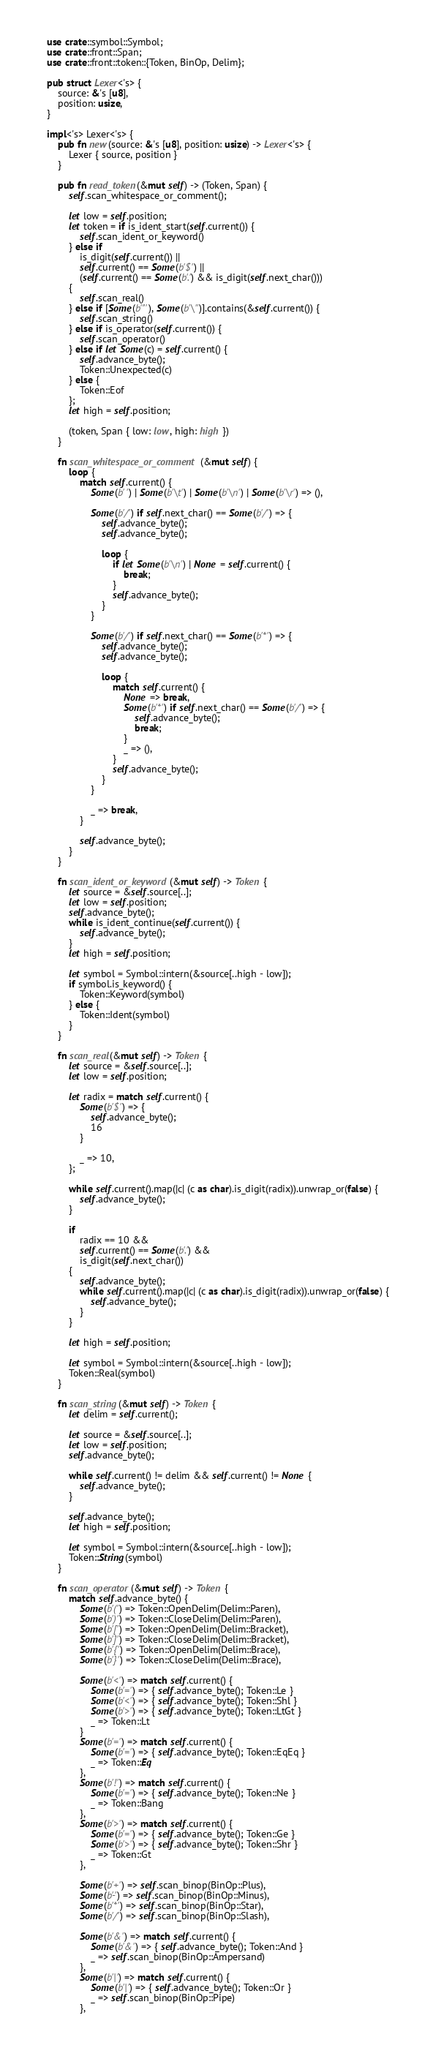Convert code to text. <code><loc_0><loc_0><loc_500><loc_500><_Rust_>use crate::symbol::Symbol;
use crate::front::Span;
use crate::front::token::{Token, BinOp, Delim};

pub struct Lexer<'s> {
    source: &'s [u8],
    position: usize,
}

impl<'s> Lexer<'s> {
    pub fn new(source: &'s [u8], position: usize) -> Lexer<'s> {
        Lexer { source, position }
    }

    pub fn read_token(&mut self) -> (Token, Span) {
        self.scan_whitespace_or_comment();

        let low = self.position;
        let token = if is_ident_start(self.current()) {
            self.scan_ident_or_keyword()
        } else if
            is_digit(self.current()) ||
            self.current() == Some(b'$') ||
            (self.current() == Some(b'.') && is_digit(self.next_char()))
        {
            self.scan_real()
        } else if [Some(b'"'), Some(b'\'')].contains(&self.current()) {
            self.scan_string()
        } else if is_operator(self.current()) {
            self.scan_operator()
        } else if let Some(c) = self.current() {
            self.advance_byte();
            Token::Unexpected(c)
        } else {
            Token::Eof
        };
        let high = self.position;

        (token, Span { low: low, high: high })
    }

    fn scan_whitespace_or_comment(&mut self) {
        loop {
            match self.current() {
                Some(b' ') | Some(b'\t') | Some(b'\n') | Some(b'\r') => (),

                Some(b'/') if self.next_char() == Some(b'/') => {
                    self.advance_byte();
                    self.advance_byte();

                    loop {
                        if let Some(b'\n') | None = self.current() {
                            break;
                        }
                        self.advance_byte();
                    }
                }

                Some(b'/') if self.next_char() == Some(b'*') => {
                    self.advance_byte();
                    self.advance_byte();

                    loop {
                        match self.current() {
                            None => break,
                            Some(b'*') if self.next_char() == Some(b'/') => {
                                self.advance_byte();
                                break;
                            }
                            _ => (),
                        }
                        self.advance_byte();
                    }
                }

                _ => break,
            }

            self.advance_byte();
        }
    }

    fn scan_ident_or_keyword(&mut self) -> Token {
        let source = &self.source[..];
        let low = self.position;
        self.advance_byte();
        while is_ident_continue(self.current()) {
            self.advance_byte();
        }
        let high = self.position;

        let symbol = Symbol::intern(&source[..high - low]);
        if symbol.is_keyword() {
            Token::Keyword(symbol)
        } else {
            Token::Ident(symbol)
        }
    }

    fn scan_real(&mut self) -> Token {
        let source = &self.source[..];
        let low = self.position;

        let radix = match self.current() {
            Some(b'$') => {
                self.advance_byte();
                16
            }

            _ => 10,
        };

        while self.current().map(|c| (c as char).is_digit(radix)).unwrap_or(false) {
            self.advance_byte();
        }

        if
            radix == 10 &&
            self.current() == Some(b'.') &&
            is_digit(self.next_char())
        {
            self.advance_byte();
            while self.current().map(|c| (c as char).is_digit(radix)).unwrap_or(false) {
                self.advance_byte();
            }
        }

        let high = self.position;

        let symbol = Symbol::intern(&source[..high - low]);
        Token::Real(symbol)
    }

    fn scan_string(&mut self) -> Token {
        let delim = self.current();

        let source = &self.source[..];
        let low = self.position;
        self.advance_byte();

        while self.current() != delim && self.current() != None {
            self.advance_byte();
        }

        self.advance_byte();
        let high = self.position;

        let symbol = Symbol::intern(&source[..high - low]);
        Token::String(symbol)
    }

    fn scan_operator(&mut self) -> Token {
        match self.advance_byte() {
            Some(b'(') => Token::OpenDelim(Delim::Paren),
            Some(b')') => Token::CloseDelim(Delim::Paren),
            Some(b'[') => Token::OpenDelim(Delim::Bracket),
            Some(b']') => Token::CloseDelim(Delim::Bracket),
            Some(b'{') => Token::OpenDelim(Delim::Brace),
            Some(b'}') => Token::CloseDelim(Delim::Brace),

            Some(b'<') => match self.current() {
                Some(b'=') => { self.advance_byte(); Token::Le }
                Some(b'<') => { self.advance_byte(); Token::Shl }
                Some(b'>') => { self.advance_byte(); Token::LtGt }
                _ => Token::Lt
            }
            Some(b'=') => match self.current() {
                Some(b'=') => { self.advance_byte(); Token::EqEq }
                _ => Token::Eq
            },
            Some(b'!') => match self.current() {
                Some(b'=') => { self.advance_byte(); Token::Ne }
                _ => Token::Bang
            },
            Some(b'>') => match self.current() {
                Some(b'=') => { self.advance_byte(); Token::Ge }
                Some(b'>') => { self.advance_byte(); Token::Shr }
                _ => Token::Gt
            },

            Some(b'+') => self.scan_binop(BinOp::Plus),
            Some(b'-') => self.scan_binop(BinOp::Minus),
            Some(b'*') => self.scan_binop(BinOp::Star),
            Some(b'/') => self.scan_binop(BinOp::Slash),

            Some(b'&') => match self.current() {
                Some(b'&') => { self.advance_byte(); Token::And }
                _ => self.scan_binop(BinOp::Ampersand)
            },
            Some(b'|') => match self.current() {
                Some(b'|') => { self.advance_byte(); Token::Or }
                _ => self.scan_binop(BinOp::Pipe)
            },</code> 